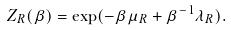Convert formula to latex. <formula><loc_0><loc_0><loc_500><loc_500>Z _ { R } ( \beta ) = \exp ( - \beta \mu _ { R } + \beta ^ { - 1 } \lambda _ { R } ) .</formula> 